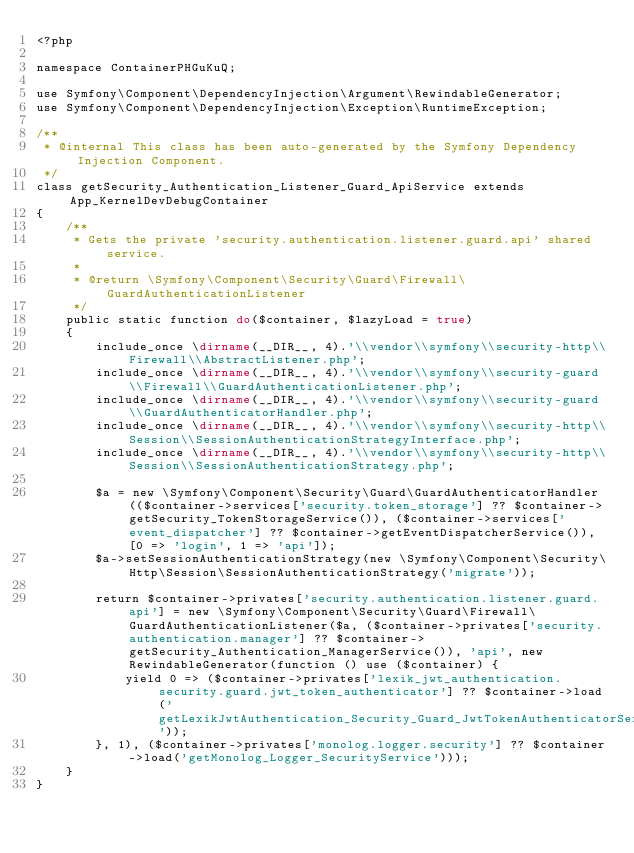<code> <loc_0><loc_0><loc_500><loc_500><_PHP_><?php

namespace ContainerPHGuKuQ;

use Symfony\Component\DependencyInjection\Argument\RewindableGenerator;
use Symfony\Component\DependencyInjection\Exception\RuntimeException;

/**
 * @internal This class has been auto-generated by the Symfony Dependency Injection Component.
 */
class getSecurity_Authentication_Listener_Guard_ApiService extends App_KernelDevDebugContainer
{
    /**
     * Gets the private 'security.authentication.listener.guard.api' shared service.
     *
     * @return \Symfony\Component\Security\Guard\Firewall\GuardAuthenticationListener
     */
    public static function do($container, $lazyLoad = true)
    {
        include_once \dirname(__DIR__, 4).'\\vendor\\symfony\\security-http\\Firewall\\AbstractListener.php';
        include_once \dirname(__DIR__, 4).'\\vendor\\symfony\\security-guard\\Firewall\\GuardAuthenticationListener.php';
        include_once \dirname(__DIR__, 4).'\\vendor\\symfony\\security-guard\\GuardAuthenticatorHandler.php';
        include_once \dirname(__DIR__, 4).'\\vendor\\symfony\\security-http\\Session\\SessionAuthenticationStrategyInterface.php';
        include_once \dirname(__DIR__, 4).'\\vendor\\symfony\\security-http\\Session\\SessionAuthenticationStrategy.php';

        $a = new \Symfony\Component\Security\Guard\GuardAuthenticatorHandler(($container->services['security.token_storage'] ?? $container->getSecurity_TokenStorageService()), ($container->services['event_dispatcher'] ?? $container->getEventDispatcherService()), [0 => 'login', 1 => 'api']);
        $a->setSessionAuthenticationStrategy(new \Symfony\Component\Security\Http\Session\SessionAuthenticationStrategy('migrate'));

        return $container->privates['security.authentication.listener.guard.api'] = new \Symfony\Component\Security\Guard\Firewall\GuardAuthenticationListener($a, ($container->privates['security.authentication.manager'] ?? $container->getSecurity_Authentication_ManagerService()), 'api', new RewindableGenerator(function () use ($container) {
            yield 0 => ($container->privates['lexik_jwt_authentication.security.guard.jwt_token_authenticator'] ?? $container->load('getLexikJwtAuthentication_Security_Guard_JwtTokenAuthenticatorService'));
        }, 1), ($container->privates['monolog.logger.security'] ?? $container->load('getMonolog_Logger_SecurityService')));
    }
}
</code> 